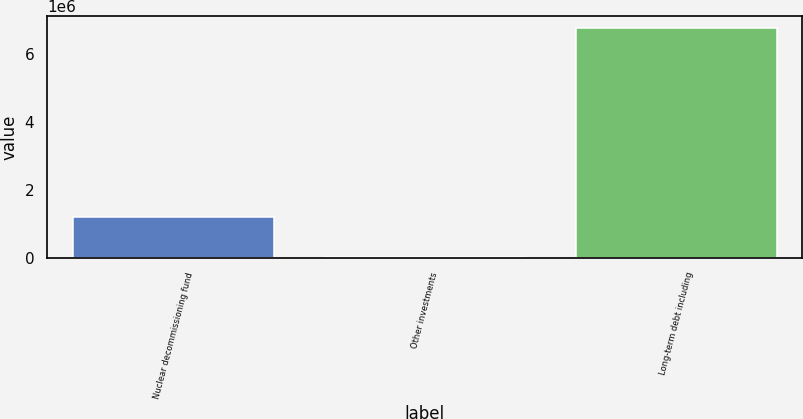<chart> <loc_0><loc_0><loc_500><loc_500><bar_chart><fcel>Nuclear decommissioning fund<fcel>Other investments<fcel>Long-term debt including<nl><fcel>1.20069e+06<fcel>29209<fcel>6.78605e+06<nl></chart> 